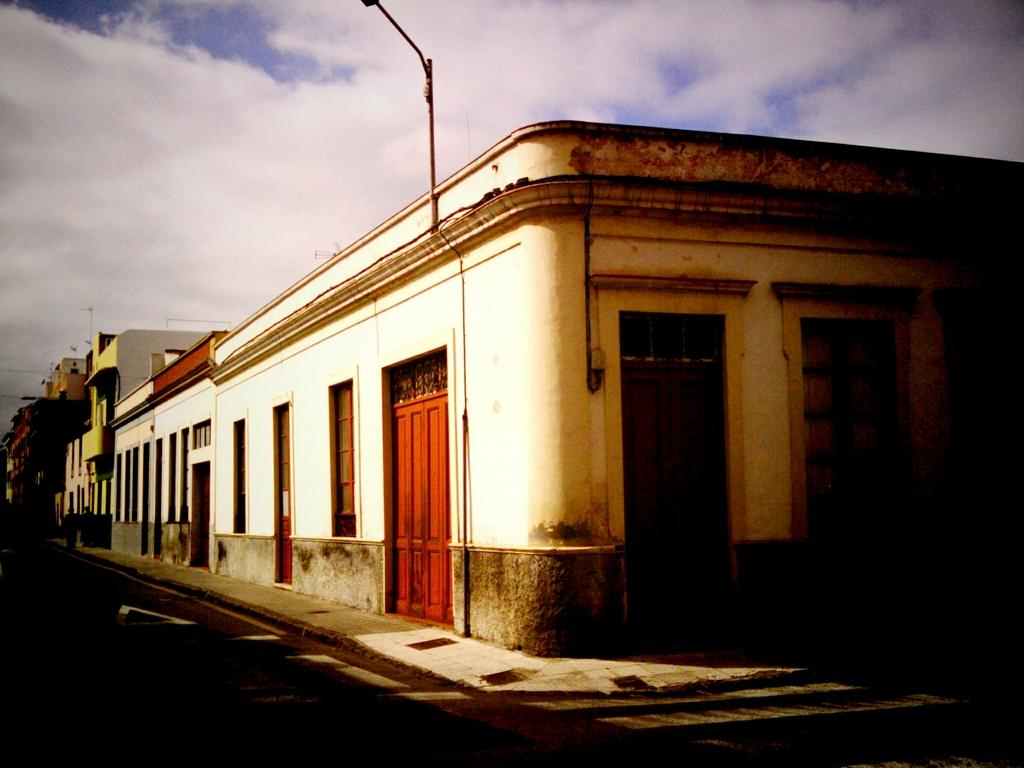What type of structures can be seen in the image? There are buildings in the image. What is located at the bottom of the image? There is a road at the bottom of the image. What can be seen in the sky in the image? There are clouds in the sky. Where is the queen wearing her glove in the image? There is no queen or glove present in the image. 